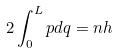<formula> <loc_0><loc_0><loc_500><loc_500>2 \int _ { 0 } ^ { L } p d q = n h</formula> 